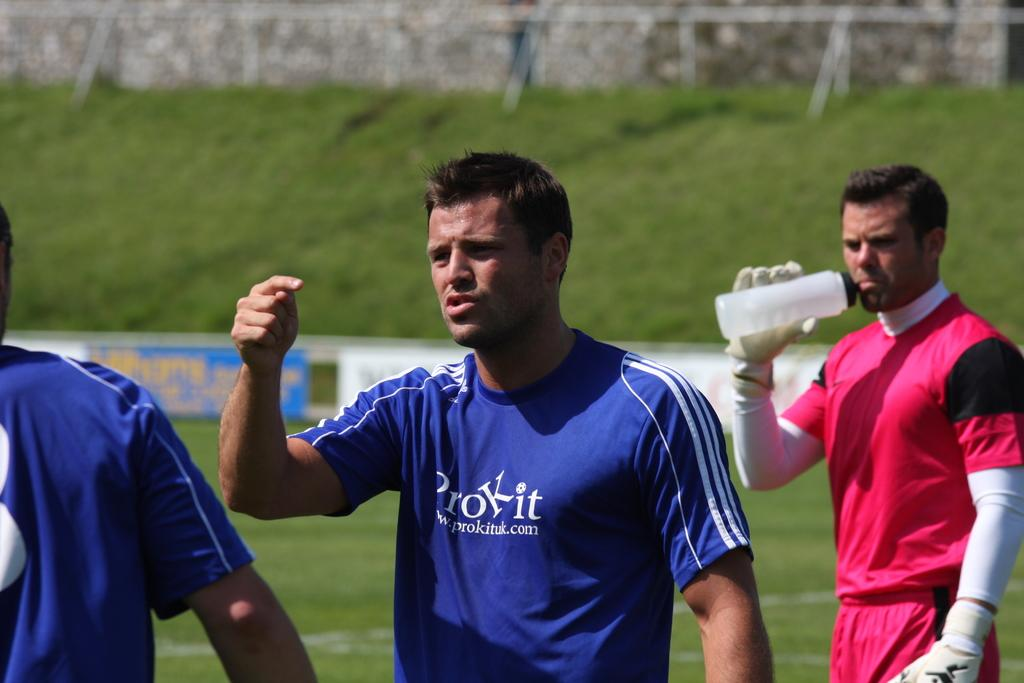How many people are in the foreground of the image? There are three persons standing in the foreground of the image. What is one person doing in the image? One person is holding a bottle and drinking. What can be seen in the background of the image? There is grass, a wall, and a board in the background of the image. What type of trucks can be seen in the image? There are no trucks present in the image. How many feet are visible in the image? The number of feet visible in the image cannot be determined from the provided facts. 